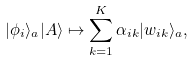Convert formula to latex. <formula><loc_0><loc_0><loc_500><loc_500>| \phi _ { i } \rangle _ { a } | A \rangle \mapsto \sum _ { k = 1 } ^ { K } \alpha _ { i k } | w _ { i k } \rangle _ { a } ,</formula> 